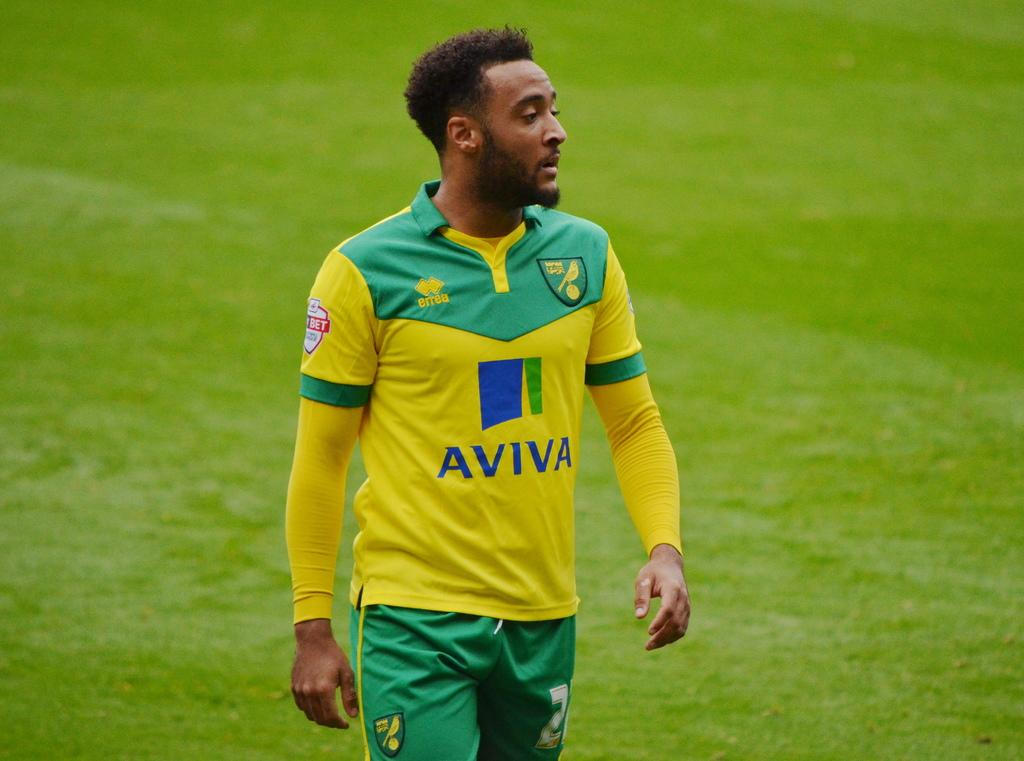<image>
Give a short and clear explanation of the subsequent image. A man is wearing a sport jersey with Aviva as the sponsor of the team. 